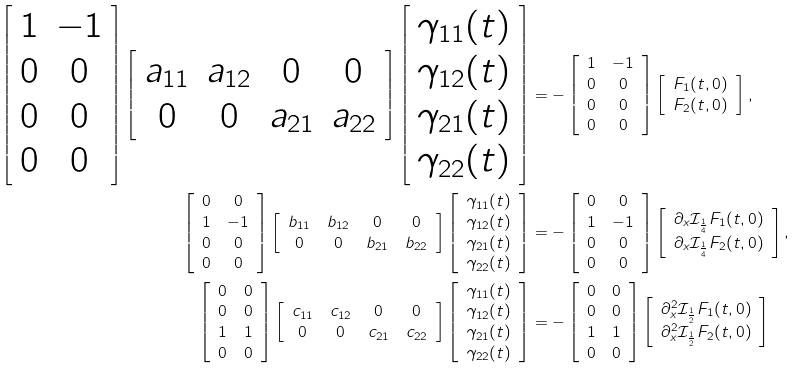Convert formula to latex. <formula><loc_0><loc_0><loc_500><loc_500>\left [ \begin{array} { c c } 1 & - 1 \\ 0 & 0 \\ 0 & 0 \\ 0 & 0 \\ \end{array} \right ] \left [ \begin{array} { c c c c } a _ { 1 1 } & a _ { 1 2 } & 0 & 0 \\ 0 & 0 & a _ { 2 1 } & a _ { 2 2 } \\ \end{array} \right ] \left [ \begin{array} { r } \gamma _ { 1 1 } ( t ) \\ \gamma _ { 1 2 } ( t ) \\ \gamma _ { 2 1 } ( t ) \\ \gamma _ { 2 2 } ( t ) \\ \end{array} \right ] & = - \left [ \begin{array} { c c } 1 & - 1 \\ 0 & 0 \\ 0 & 0 \\ 0 & 0 \\ \end{array} \right ] \left [ \begin{array} { r } F _ { 1 } ( t , 0 ) \\ F _ { 2 } ( t , 0 ) \\ \end{array} \right ] , \\ \left [ \begin{array} { c c } 0 & 0 \\ 1 & - 1 \\ 0 & 0 \\ 0 & 0 \\ \end{array} \right ] \left [ \begin{array} { c c c c } b _ { 1 1 } & b _ { 1 2 } & 0 & 0 \\ 0 & 0 & b _ { 2 1 } & b _ { 2 2 } \\ \end{array} \right ] \left [ \begin{array} { r } \gamma _ { 1 1 } ( t ) \\ \gamma _ { 1 2 } ( t ) \\ \gamma _ { 2 1 } ( t ) \\ \gamma _ { 2 2 } ( t ) \\ \end{array} \right ] & = - \left [ \begin{array} { c c } 0 & 0 \\ 1 & - 1 \\ 0 & 0 \\ 0 & 0 \\ \end{array} \right ] \left [ \begin{array} { r } \partial _ { x } \mathcal { I } _ { \frac { 1 } { 4 } } F _ { 1 } ( t , 0 ) \\ \partial _ { x } \mathcal { I } _ { \frac { 1 } { 4 } } F _ { 2 } ( t , 0 ) \\ \end{array} \right ] , \\ \left [ \begin{array} { c c } 0 & 0 \\ 0 & 0 \\ 1 & 1 \\ 0 & 0 \\ \end{array} \right ] \left [ \begin{array} { c c c c } c _ { 1 1 } & c _ { 1 2 } & 0 & 0 \\ 0 & 0 & c _ { 2 1 } & c _ { 2 2 } \\ \end{array} \right ] \left [ \begin{array} { r } \gamma _ { 1 1 } ( t ) \\ \gamma _ { 1 2 } ( t ) \\ \gamma _ { 2 1 } ( t ) \\ \gamma _ { 2 2 } ( t ) \\ \end{array} \right ] & = - \left [ \begin{array} { c c } 0 & 0 \\ 0 & 0 \\ 1 & 1 \\ 0 & 0 \\ \end{array} \right ] \left [ \begin{array} { r } \partial _ { x } ^ { 2 } \mathcal { I } _ { \frac { 1 } { 2 } } F _ { 1 } ( t , 0 ) \\ \partial _ { x } ^ { 2 } \mathcal { I } _ { \frac { 1 } { 2 } } F _ { 2 } ( t , 0 ) \\ \end{array} \right ]</formula> 